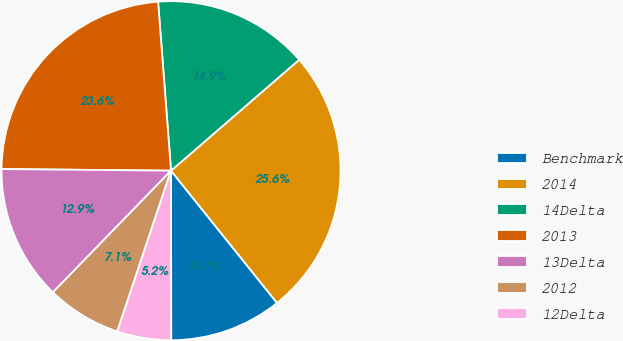Convert chart to OTSL. <chart><loc_0><loc_0><loc_500><loc_500><pie_chart><fcel>Benchmark<fcel>2014<fcel>14Delta<fcel>2013<fcel>13Delta<fcel>2012<fcel>12Delta<nl><fcel>10.74%<fcel>25.6%<fcel>14.86%<fcel>23.63%<fcel>12.89%<fcel>7.13%<fcel>5.15%<nl></chart> 